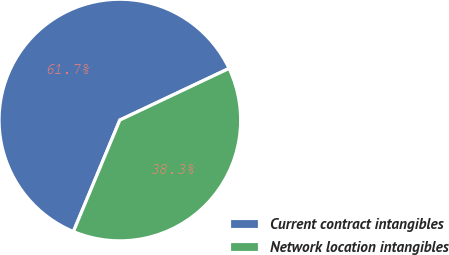Convert chart. <chart><loc_0><loc_0><loc_500><loc_500><pie_chart><fcel>Current contract intangibles<fcel>Network location intangibles<nl><fcel>61.69%<fcel>38.31%<nl></chart> 